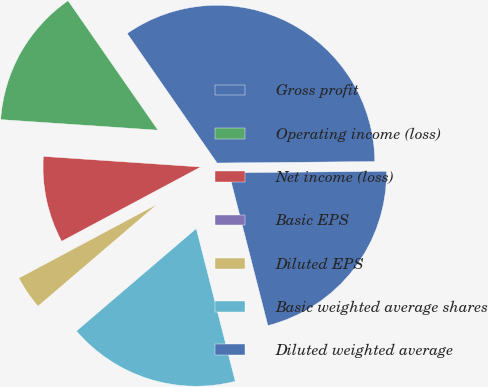<chart> <loc_0><loc_0><loc_500><loc_500><pie_chart><fcel>Gross profit<fcel>Operating income (loss)<fcel>Net income (loss)<fcel>Basic EPS<fcel>Diluted EPS<fcel>Basic weighted average shares<fcel>Diluted weighted average<nl><fcel>34.51%<fcel>14.27%<fcel>8.88%<fcel>0.0%<fcel>3.45%<fcel>17.72%<fcel>21.17%<nl></chart> 